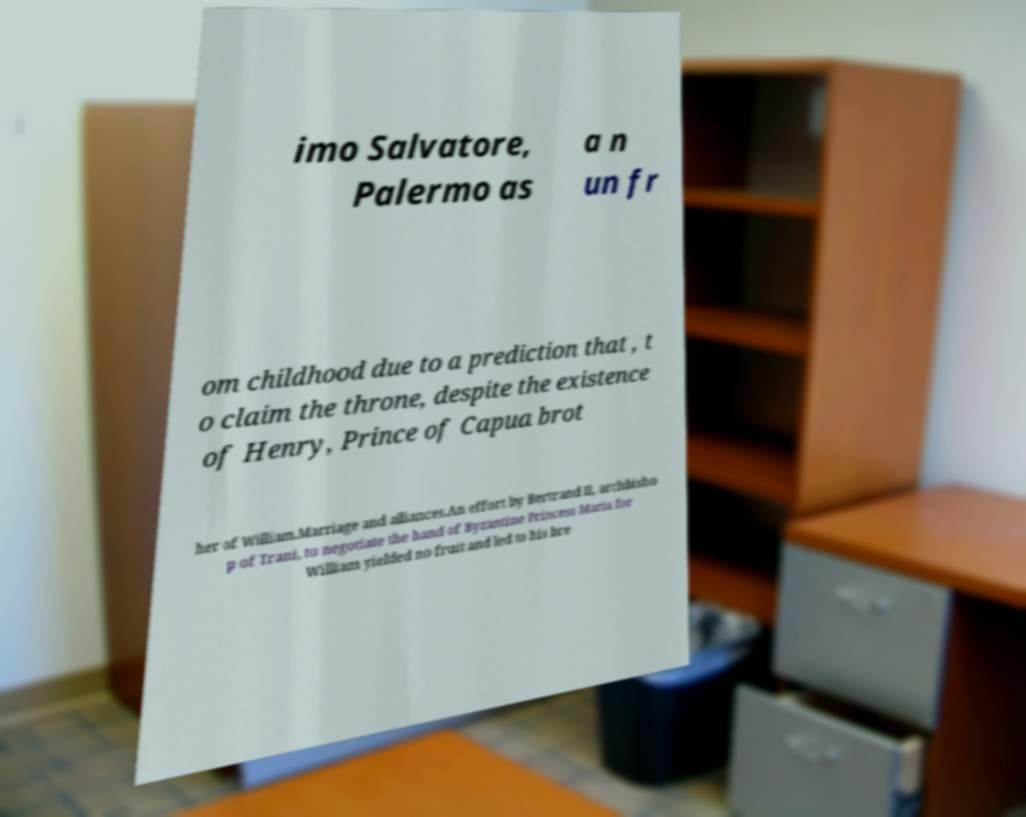Could you assist in decoding the text presented in this image and type it out clearly? imo Salvatore, Palermo as a n un fr om childhood due to a prediction that , t o claim the throne, despite the existence of Henry, Prince of Capua brot her of William.Marriage and alliances.An effort by Bertrand II, archbisho p of Trani, to negotiate the hand of Byzantine Princess Maria for William yielded no fruit and led to his bre 